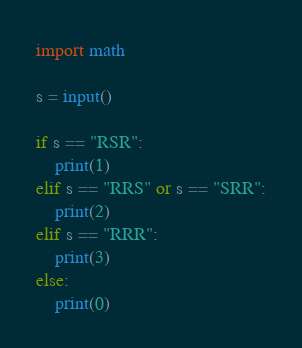<code> <loc_0><loc_0><loc_500><loc_500><_Python_>import math

s = input()

if s == "RSR":
    print(1)
elif s == "RRS" or s == "SRR":
    print(2)
elif s == "RRR":
    print(3)
else:
    print(0)</code> 